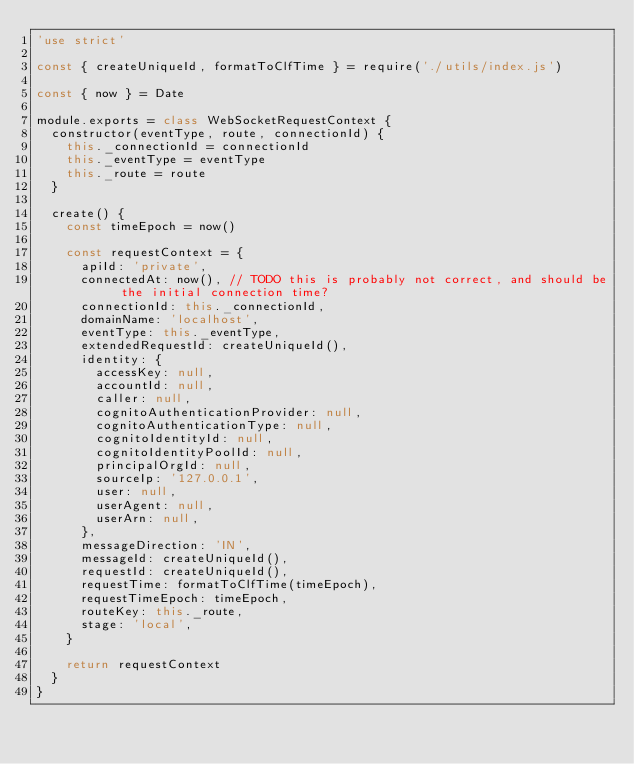Convert code to text. <code><loc_0><loc_0><loc_500><loc_500><_JavaScript_>'use strict'

const { createUniqueId, formatToClfTime } = require('./utils/index.js')

const { now } = Date

module.exports = class WebSocketRequestContext {
  constructor(eventType, route, connectionId) {
    this._connectionId = connectionId
    this._eventType = eventType
    this._route = route
  }

  create() {
    const timeEpoch = now()

    const requestContext = {
      apiId: 'private',
      connectedAt: now(), // TODO this is probably not correct, and should be the initial connection time?
      connectionId: this._connectionId,
      domainName: 'localhost',
      eventType: this._eventType,
      extendedRequestId: createUniqueId(),
      identity: {
        accessKey: null,
        accountId: null,
        caller: null,
        cognitoAuthenticationProvider: null,
        cognitoAuthenticationType: null,
        cognitoIdentityId: null,
        cognitoIdentityPoolId: null,
        principalOrgId: null,
        sourceIp: '127.0.0.1',
        user: null,
        userAgent: null,
        userArn: null,
      },
      messageDirection: 'IN',
      messageId: createUniqueId(),
      requestId: createUniqueId(),
      requestTime: formatToClfTime(timeEpoch),
      requestTimeEpoch: timeEpoch,
      routeKey: this._route,
      stage: 'local',
    }

    return requestContext
  }
}
</code> 